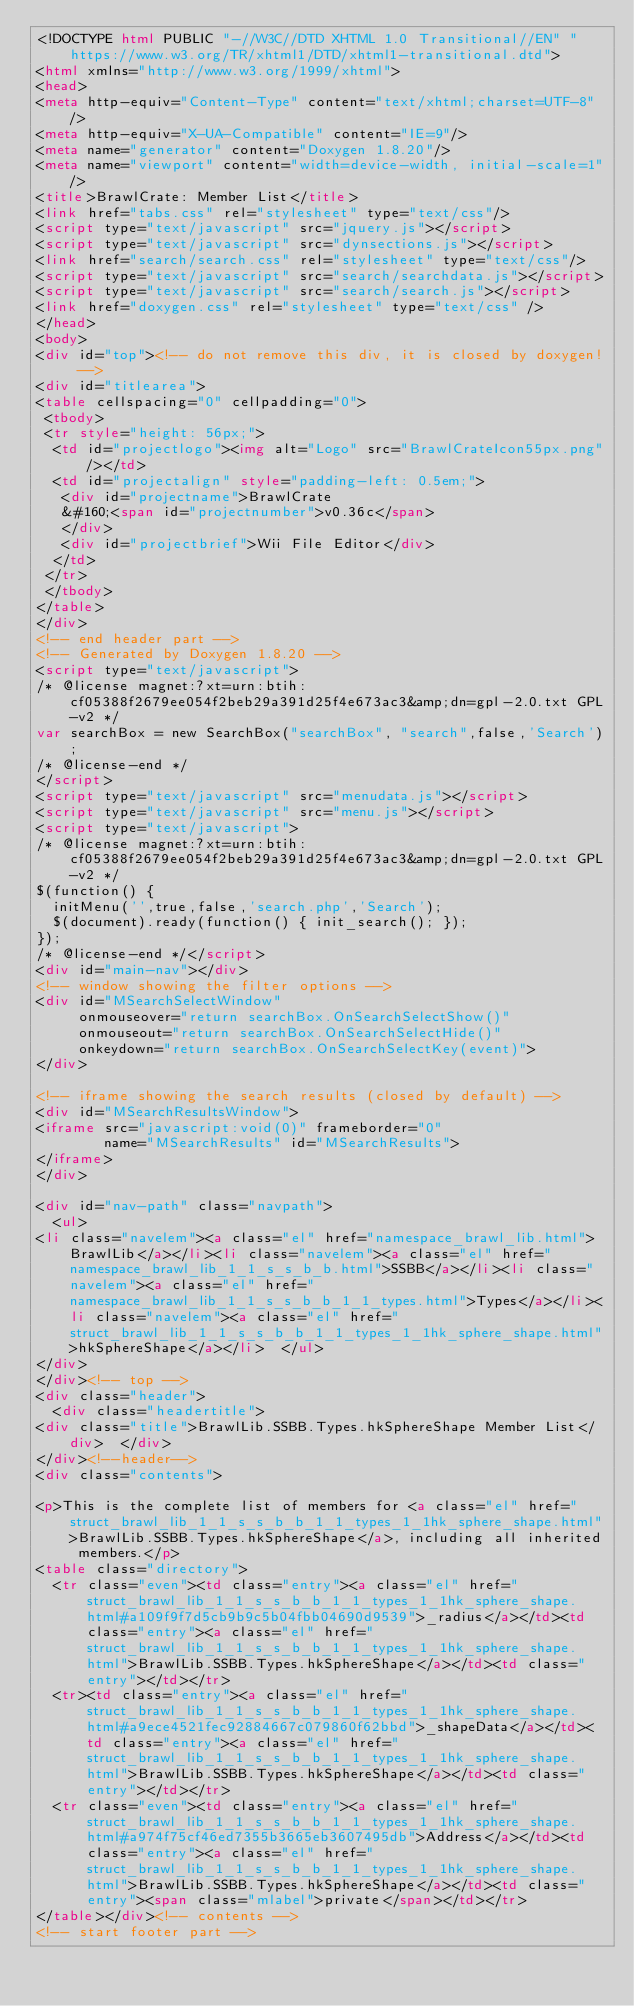Convert code to text. <code><loc_0><loc_0><loc_500><loc_500><_HTML_><!DOCTYPE html PUBLIC "-//W3C//DTD XHTML 1.0 Transitional//EN" "https://www.w3.org/TR/xhtml1/DTD/xhtml1-transitional.dtd">
<html xmlns="http://www.w3.org/1999/xhtml">
<head>
<meta http-equiv="Content-Type" content="text/xhtml;charset=UTF-8"/>
<meta http-equiv="X-UA-Compatible" content="IE=9"/>
<meta name="generator" content="Doxygen 1.8.20"/>
<meta name="viewport" content="width=device-width, initial-scale=1"/>
<title>BrawlCrate: Member List</title>
<link href="tabs.css" rel="stylesheet" type="text/css"/>
<script type="text/javascript" src="jquery.js"></script>
<script type="text/javascript" src="dynsections.js"></script>
<link href="search/search.css" rel="stylesheet" type="text/css"/>
<script type="text/javascript" src="search/searchdata.js"></script>
<script type="text/javascript" src="search/search.js"></script>
<link href="doxygen.css" rel="stylesheet" type="text/css" />
</head>
<body>
<div id="top"><!-- do not remove this div, it is closed by doxygen! -->
<div id="titlearea">
<table cellspacing="0" cellpadding="0">
 <tbody>
 <tr style="height: 56px;">
  <td id="projectlogo"><img alt="Logo" src="BrawlCrateIcon55px.png"/></td>
  <td id="projectalign" style="padding-left: 0.5em;">
   <div id="projectname">BrawlCrate
   &#160;<span id="projectnumber">v0.36c</span>
   </div>
   <div id="projectbrief">Wii File Editor</div>
  </td>
 </tr>
 </tbody>
</table>
</div>
<!-- end header part -->
<!-- Generated by Doxygen 1.8.20 -->
<script type="text/javascript">
/* @license magnet:?xt=urn:btih:cf05388f2679ee054f2beb29a391d25f4e673ac3&amp;dn=gpl-2.0.txt GPL-v2 */
var searchBox = new SearchBox("searchBox", "search",false,'Search');
/* @license-end */
</script>
<script type="text/javascript" src="menudata.js"></script>
<script type="text/javascript" src="menu.js"></script>
<script type="text/javascript">
/* @license magnet:?xt=urn:btih:cf05388f2679ee054f2beb29a391d25f4e673ac3&amp;dn=gpl-2.0.txt GPL-v2 */
$(function() {
  initMenu('',true,false,'search.php','Search');
  $(document).ready(function() { init_search(); });
});
/* @license-end */</script>
<div id="main-nav"></div>
<!-- window showing the filter options -->
<div id="MSearchSelectWindow"
     onmouseover="return searchBox.OnSearchSelectShow()"
     onmouseout="return searchBox.OnSearchSelectHide()"
     onkeydown="return searchBox.OnSearchSelectKey(event)">
</div>

<!-- iframe showing the search results (closed by default) -->
<div id="MSearchResultsWindow">
<iframe src="javascript:void(0)" frameborder="0" 
        name="MSearchResults" id="MSearchResults">
</iframe>
</div>

<div id="nav-path" class="navpath">
  <ul>
<li class="navelem"><a class="el" href="namespace_brawl_lib.html">BrawlLib</a></li><li class="navelem"><a class="el" href="namespace_brawl_lib_1_1_s_s_b_b.html">SSBB</a></li><li class="navelem"><a class="el" href="namespace_brawl_lib_1_1_s_s_b_b_1_1_types.html">Types</a></li><li class="navelem"><a class="el" href="struct_brawl_lib_1_1_s_s_b_b_1_1_types_1_1hk_sphere_shape.html">hkSphereShape</a></li>  </ul>
</div>
</div><!-- top -->
<div class="header">
  <div class="headertitle">
<div class="title">BrawlLib.SSBB.Types.hkSphereShape Member List</div>  </div>
</div><!--header-->
<div class="contents">

<p>This is the complete list of members for <a class="el" href="struct_brawl_lib_1_1_s_s_b_b_1_1_types_1_1hk_sphere_shape.html">BrawlLib.SSBB.Types.hkSphereShape</a>, including all inherited members.</p>
<table class="directory">
  <tr class="even"><td class="entry"><a class="el" href="struct_brawl_lib_1_1_s_s_b_b_1_1_types_1_1hk_sphere_shape.html#a109f9f7d5cb9b9c5b04fbb04690d9539">_radius</a></td><td class="entry"><a class="el" href="struct_brawl_lib_1_1_s_s_b_b_1_1_types_1_1hk_sphere_shape.html">BrawlLib.SSBB.Types.hkSphereShape</a></td><td class="entry"></td></tr>
  <tr><td class="entry"><a class="el" href="struct_brawl_lib_1_1_s_s_b_b_1_1_types_1_1hk_sphere_shape.html#a9ece4521fec92884667c079860f62bbd">_shapeData</a></td><td class="entry"><a class="el" href="struct_brawl_lib_1_1_s_s_b_b_1_1_types_1_1hk_sphere_shape.html">BrawlLib.SSBB.Types.hkSphereShape</a></td><td class="entry"></td></tr>
  <tr class="even"><td class="entry"><a class="el" href="struct_brawl_lib_1_1_s_s_b_b_1_1_types_1_1hk_sphere_shape.html#a974f75cf46ed7355b3665eb3607495db">Address</a></td><td class="entry"><a class="el" href="struct_brawl_lib_1_1_s_s_b_b_1_1_types_1_1hk_sphere_shape.html">BrawlLib.SSBB.Types.hkSphereShape</a></td><td class="entry"><span class="mlabel">private</span></td></tr>
</table></div><!-- contents -->
<!-- start footer part --></code> 